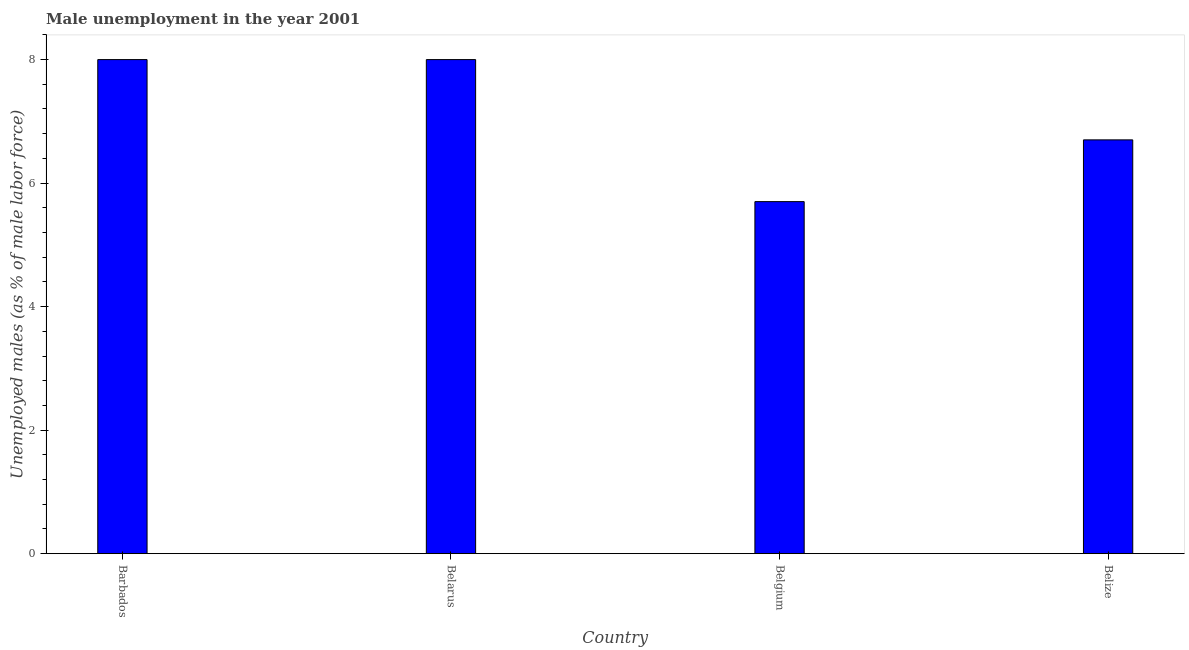Does the graph contain any zero values?
Ensure brevity in your answer.  No. Does the graph contain grids?
Make the answer very short. No. What is the title of the graph?
Your answer should be compact. Male unemployment in the year 2001. What is the label or title of the X-axis?
Provide a succinct answer. Country. What is the label or title of the Y-axis?
Make the answer very short. Unemployed males (as % of male labor force). What is the unemployed males population in Belize?
Your answer should be compact. 6.7. Across all countries, what is the minimum unemployed males population?
Your answer should be compact. 5.7. In which country was the unemployed males population maximum?
Give a very brief answer. Barbados. What is the sum of the unemployed males population?
Keep it short and to the point. 28.4. What is the median unemployed males population?
Make the answer very short. 7.35. In how many countries, is the unemployed males population greater than 3.2 %?
Offer a terse response. 4. Is the unemployed males population in Barbados less than that in Belgium?
Your answer should be compact. No. In how many countries, is the unemployed males population greater than the average unemployed males population taken over all countries?
Keep it short and to the point. 2. Are all the bars in the graph horizontal?
Provide a short and direct response. No. How many countries are there in the graph?
Provide a short and direct response. 4. What is the Unemployed males (as % of male labor force) in Barbados?
Offer a very short reply. 8. What is the Unemployed males (as % of male labor force) of Belgium?
Give a very brief answer. 5.7. What is the Unemployed males (as % of male labor force) in Belize?
Make the answer very short. 6.7. What is the difference between the Unemployed males (as % of male labor force) in Barbados and Belarus?
Provide a succinct answer. 0. What is the difference between the Unemployed males (as % of male labor force) in Barbados and Belgium?
Provide a succinct answer. 2.3. What is the ratio of the Unemployed males (as % of male labor force) in Barbados to that in Belarus?
Provide a short and direct response. 1. What is the ratio of the Unemployed males (as % of male labor force) in Barbados to that in Belgium?
Give a very brief answer. 1.4. What is the ratio of the Unemployed males (as % of male labor force) in Barbados to that in Belize?
Give a very brief answer. 1.19. What is the ratio of the Unemployed males (as % of male labor force) in Belarus to that in Belgium?
Ensure brevity in your answer.  1.4. What is the ratio of the Unemployed males (as % of male labor force) in Belarus to that in Belize?
Your response must be concise. 1.19. What is the ratio of the Unemployed males (as % of male labor force) in Belgium to that in Belize?
Offer a very short reply. 0.85. 